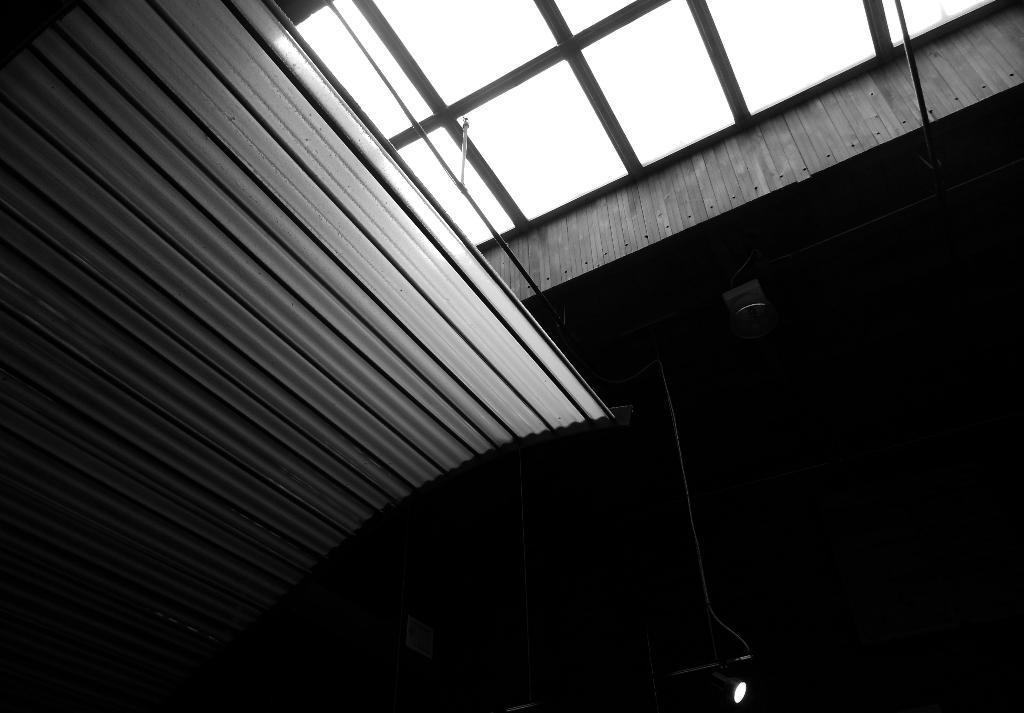Please provide a concise description of this image. This image consists of a roof to which there are metal rods. On the left, we can see a curved surface. At the bottom, we can see a lamp. And the image is too dark on the right side. 